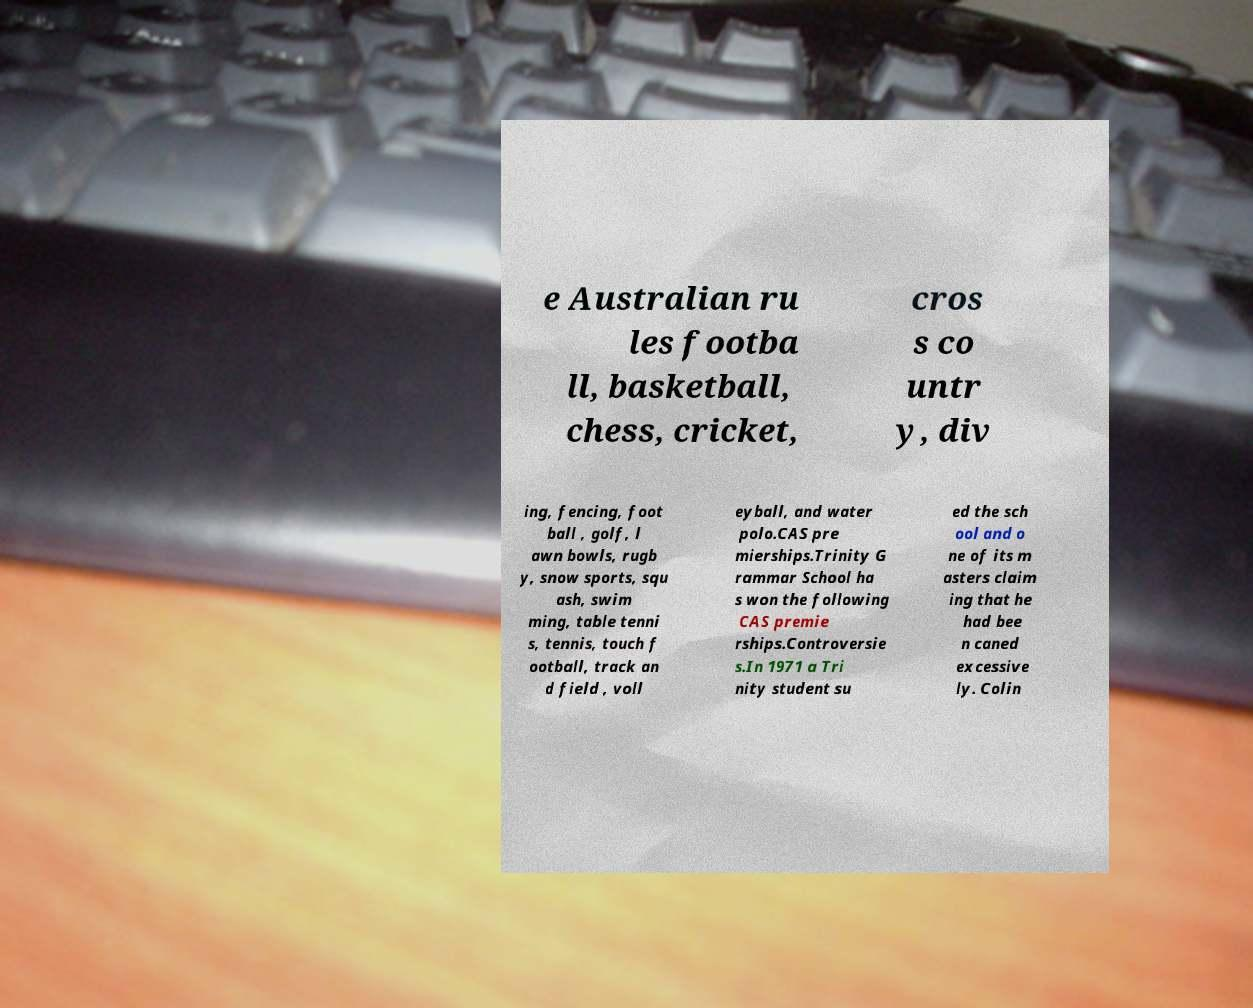Can you read and provide the text displayed in the image?This photo seems to have some interesting text. Can you extract and type it out for me? e Australian ru les footba ll, basketball, chess, cricket, cros s co untr y, div ing, fencing, foot ball , golf, l awn bowls, rugb y, snow sports, squ ash, swim ming, table tenni s, tennis, touch f ootball, track an d field , voll eyball, and water polo.CAS pre mierships.Trinity G rammar School ha s won the following CAS premie rships.Controversie s.In 1971 a Tri nity student su ed the sch ool and o ne of its m asters claim ing that he had bee n caned excessive ly. Colin 